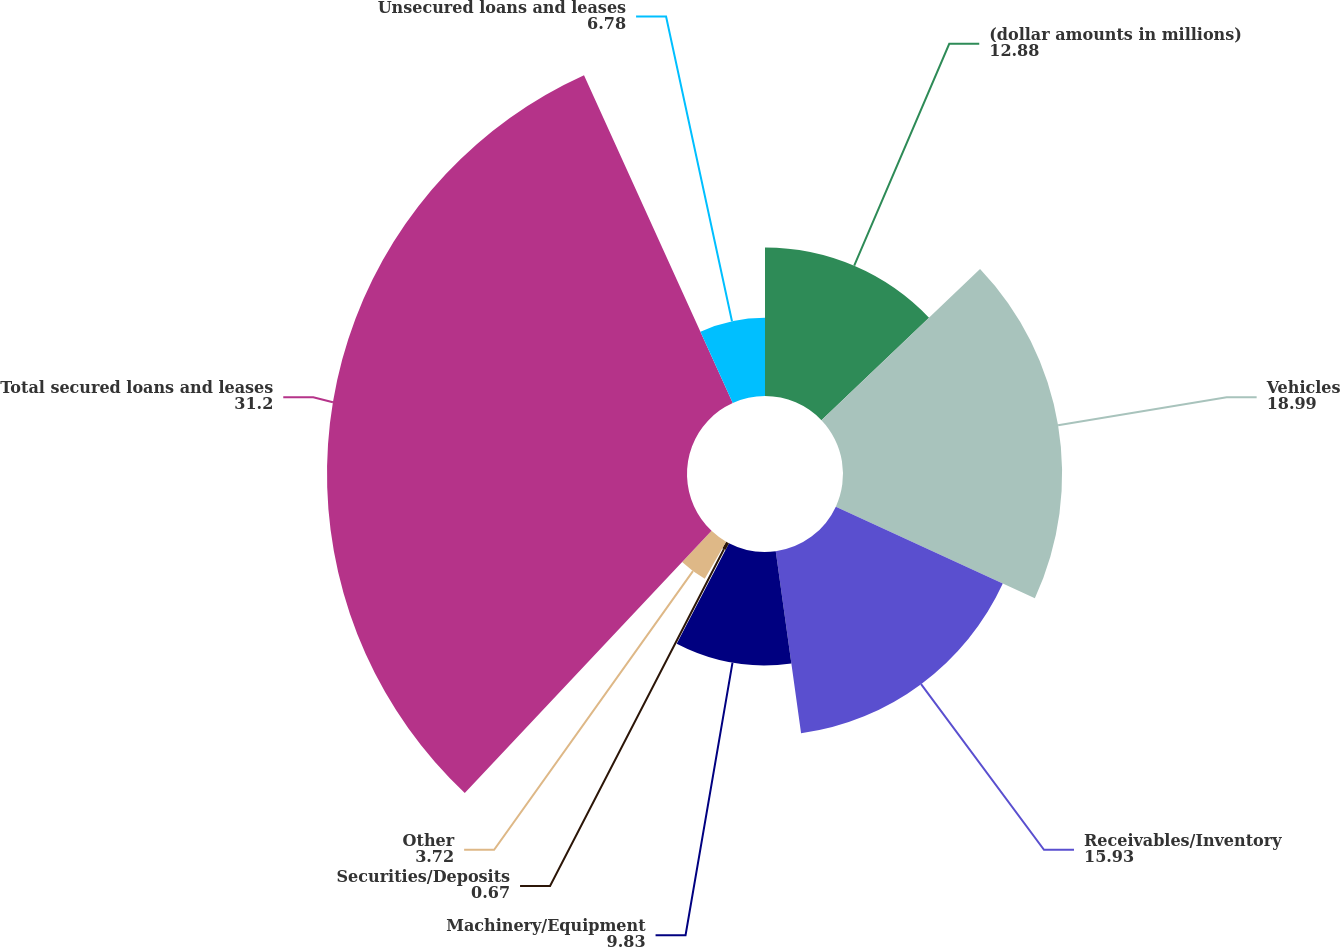Convert chart. <chart><loc_0><loc_0><loc_500><loc_500><pie_chart><fcel>(dollar amounts in millions)<fcel>Vehicles<fcel>Receivables/Inventory<fcel>Machinery/Equipment<fcel>Securities/Deposits<fcel>Other<fcel>Total secured loans and leases<fcel>Unsecured loans and leases<nl><fcel>12.88%<fcel>18.99%<fcel>15.93%<fcel>9.83%<fcel>0.67%<fcel>3.72%<fcel>31.2%<fcel>6.78%<nl></chart> 